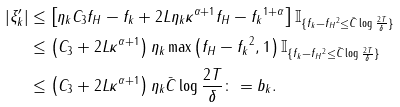Convert formula to latex. <formula><loc_0><loc_0><loc_500><loc_500>| \xi _ { k } ^ { \prime } | & \leq \left [ \eta _ { k } C _ { 3 } \| f _ { H } - f _ { k } \| + 2 L \eta _ { k } \kappa ^ { \alpha + 1 } \| f _ { H } - f _ { k } \| ^ { 1 + \alpha } \right ] \mathbb { I } _ { \{ \| f _ { k } - f _ { H } \| ^ { 2 } \leq \bar { C } \log \frac { 2 T } { \delta } \} } \\ & \leq \left ( C _ { 3 } + 2 L \kappa ^ { \alpha + 1 } \right ) \eta _ { k } \max \left ( \| f _ { H } - f _ { k } \| ^ { 2 } , 1 \right ) \mathbb { I } _ { \{ \| f _ { k } - f _ { H } \| ^ { 2 } \leq \bar { C } \log \frac { 2 T } { \delta } \} } \\ & \leq \left ( C _ { 3 } + 2 L \kappa ^ { \alpha + 1 } \right ) \eta _ { k } \bar { C } \log \frac { 2 T } { \delta } \colon = b _ { k } .</formula> 